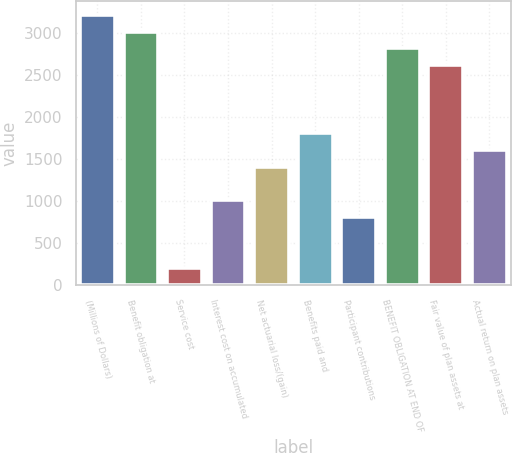<chart> <loc_0><loc_0><loc_500><loc_500><bar_chart><fcel>(Millions of Dollars)<fcel>Benefit obligation at<fcel>Service cost<fcel>Interest cost on accumulated<fcel>Net actuarial loss/(gain)<fcel>Benefits paid and<fcel>Participant contributions<fcel>BENEFIT OBLIGATION AT END OF<fcel>Fair value of plan assets at<fcel>Actual return on plan assets<nl><fcel>3221.4<fcel>3020.5<fcel>207.9<fcel>1011.5<fcel>1413.3<fcel>1815.1<fcel>810.6<fcel>2819.6<fcel>2618.7<fcel>1614.2<nl></chart> 